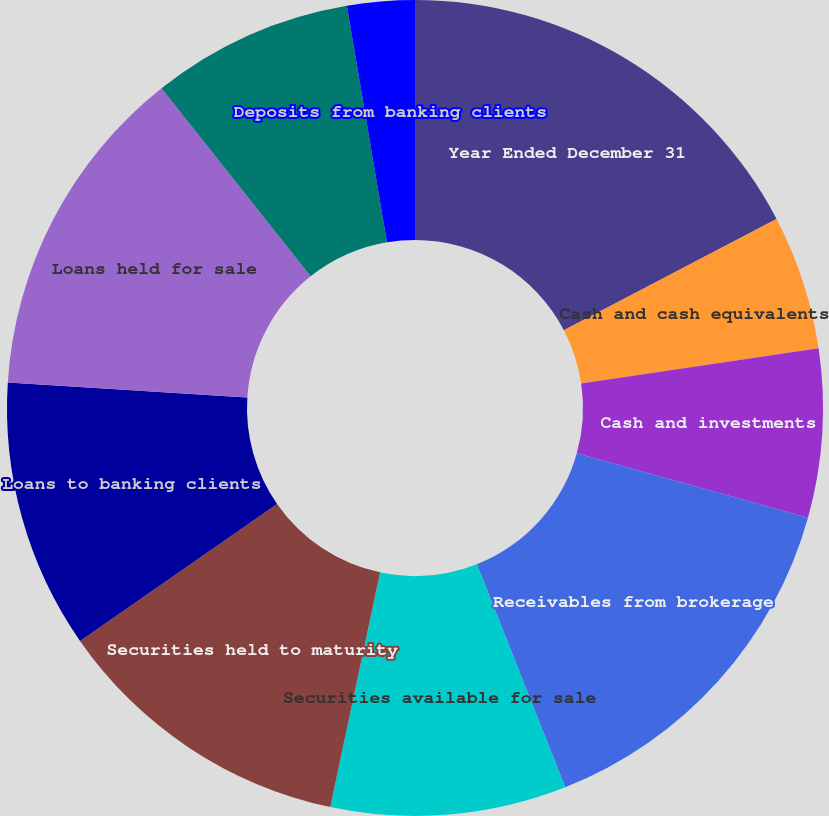<chart> <loc_0><loc_0><loc_500><loc_500><pie_chart><fcel>Year Ended December 31<fcel>Cash and cash equivalents<fcel>Cash and investments<fcel>Receivables from brokerage<fcel>Securities available for sale<fcel>Securities held to maturity<fcel>Loans to banking clients<fcel>Loans held for sale<fcel>Total interest-earning assets<fcel>Deposits from banking clients<nl><fcel>17.33%<fcel>5.33%<fcel>6.67%<fcel>14.67%<fcel>9.33%<fcel>12.0%<fcel>10.67%<fcel>13.33%<fcel>8.0%<fcel>2.67%<nl></chart> 